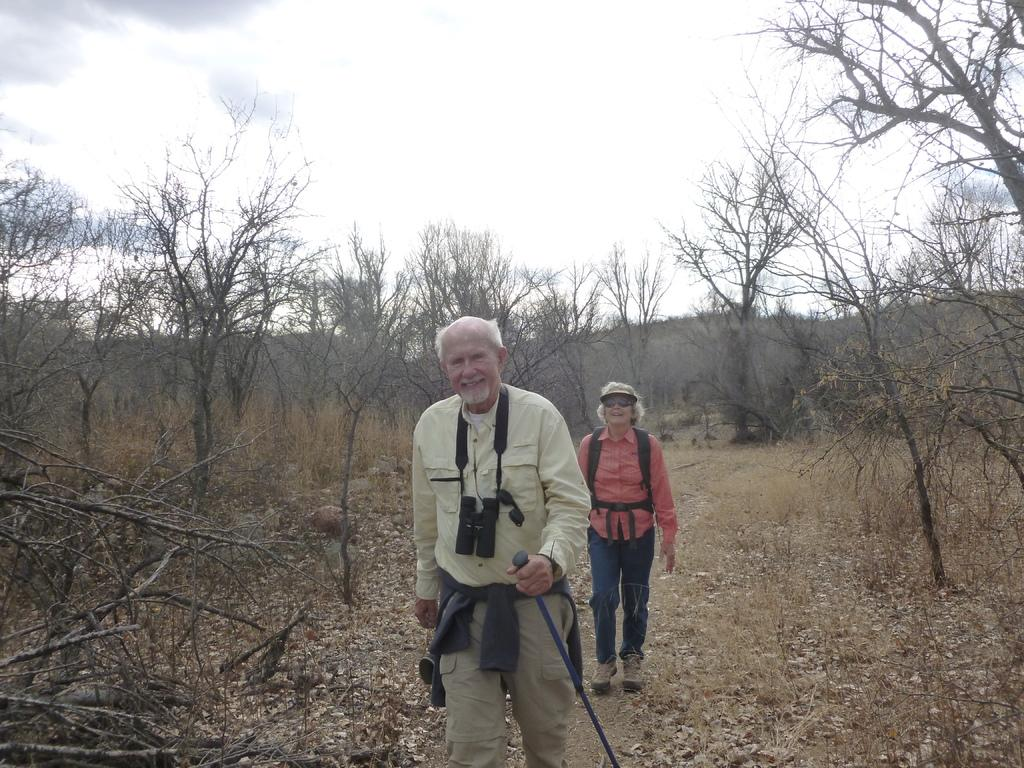What type of vegetation can be seen in the image? There are trees in the image. What else can be seen on the ground in the image? There is grass in the image. How many people are present in the image? There are two persons standing in the image. What is visible in the background of the image? The sky is visible in the background of the image. What is the income of the trees in the image? Trees do not have an income, as they are living organisms and not capable of earning money. How many sides does the grass have in the image? Grass is not a geometric shape, so it does not have sides or a specific number of them. 